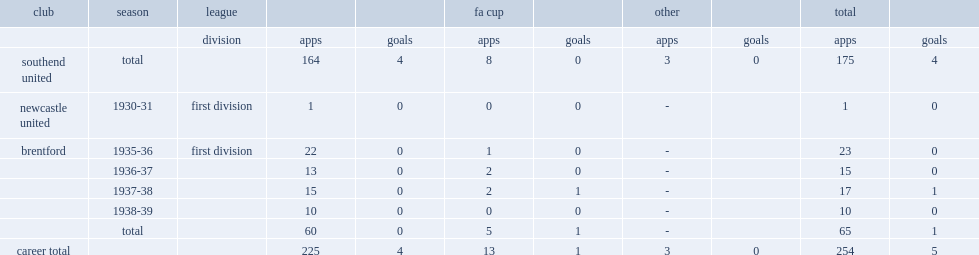Would you be able to parse every entry in this table? {'header': ['club', 'season', 'league', '', '', 'fa cup', '', 'other', '', 'total', ''], 'rows': [['', '', 'division', 'apps', 'goals', 'apps', 'goals', 'apps', 'goals', 'apps', 'goals'], ['southend united', 'total', '', '164', '4', '8', '0', '3', '0', '175', '4'], ['newcastle united', '1930-31', 'first division', '1', '0', '0', '0', '-', '', '1', '0'], ['brentford', '1935-36', 'first division', '22', '0', '1', '0', '-', '', '23', '0'], ['', '1936-37', '', '13', '0', '2', '0', '-', '', '15', '0'], ['', '1937-38', '', '15', '0', '2', '1', '-', '', '17', '1'], ['', '1938-39', '', '10', '0', '0', '0', '-', '', '10', '0'], ['', 'total', '', '60', '0', '5', '1', '-', '', '65', '1'], ['career total', '', '', '225', '4', '13', '1', '3', '0', '254', '5']]} What was the total number of apps made by joe wilson? 175.0. 